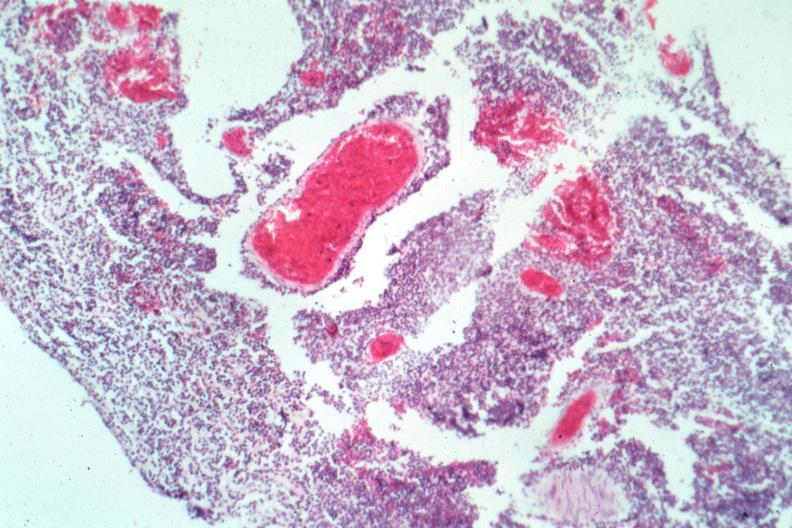s palmar crease normal present?
Answer the question using a single word or phrase. No 